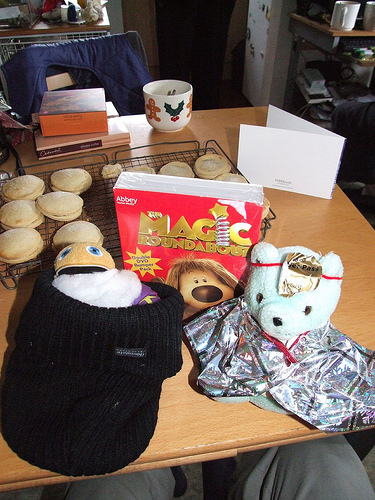<image>
Is the cookies in the box? No. The cookies is not contained within the box. These objects have a different spatial relationship. 